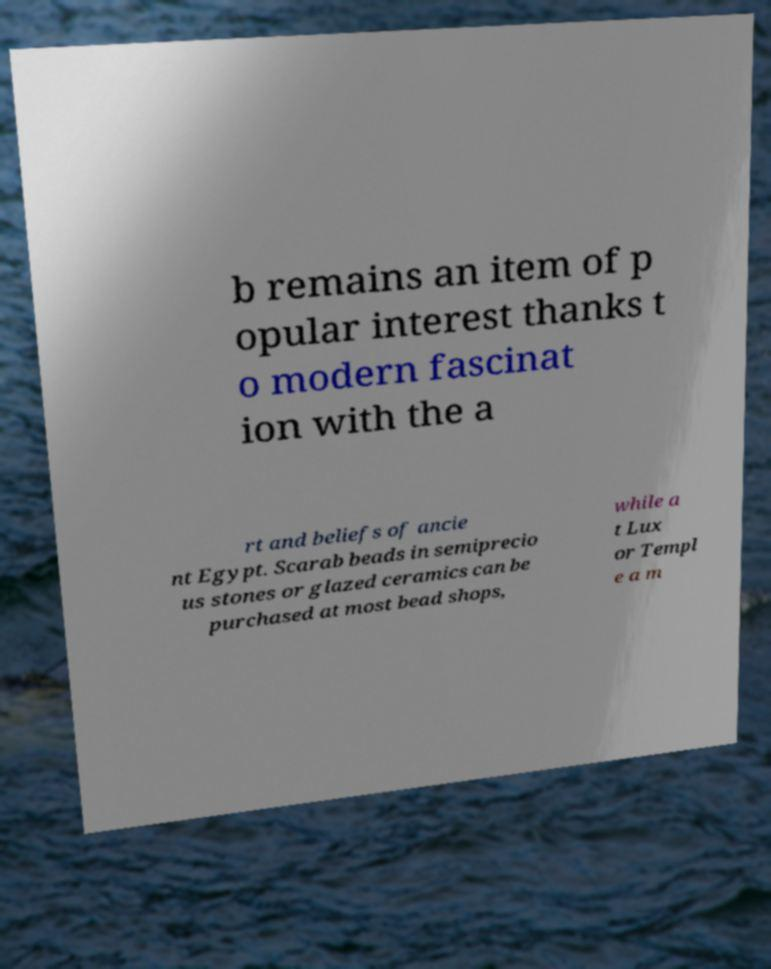What messages or text are displayed in this image? I need them in a readable, typed format. b remains an item of p opular interest thanks t o modern fascinat ion with the a rt and beliefs of ancie nt Egypt. Scarab beads in semiprecio us stones or glazed ceramics can be purchased at most bead shops, while a t Lux or Templ e a m 